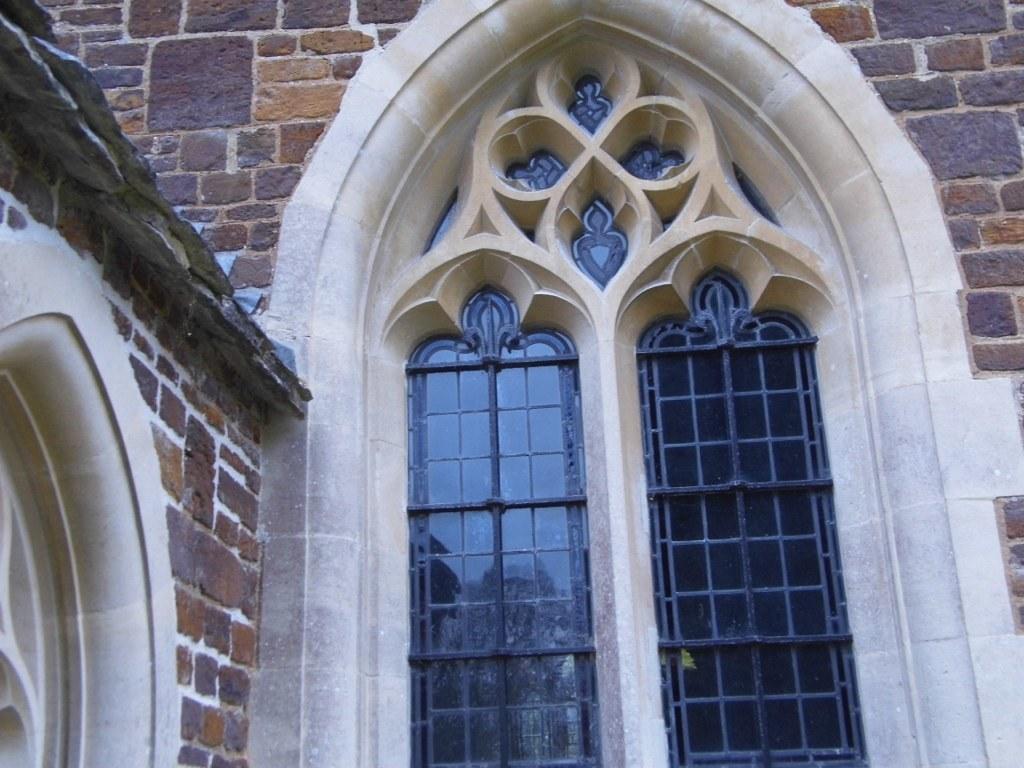In one or two sentences, can you explain what this image depicts? In this image we can see a building with two windows and we can also see an arch with design at the top of the windows. We can see the wall. 